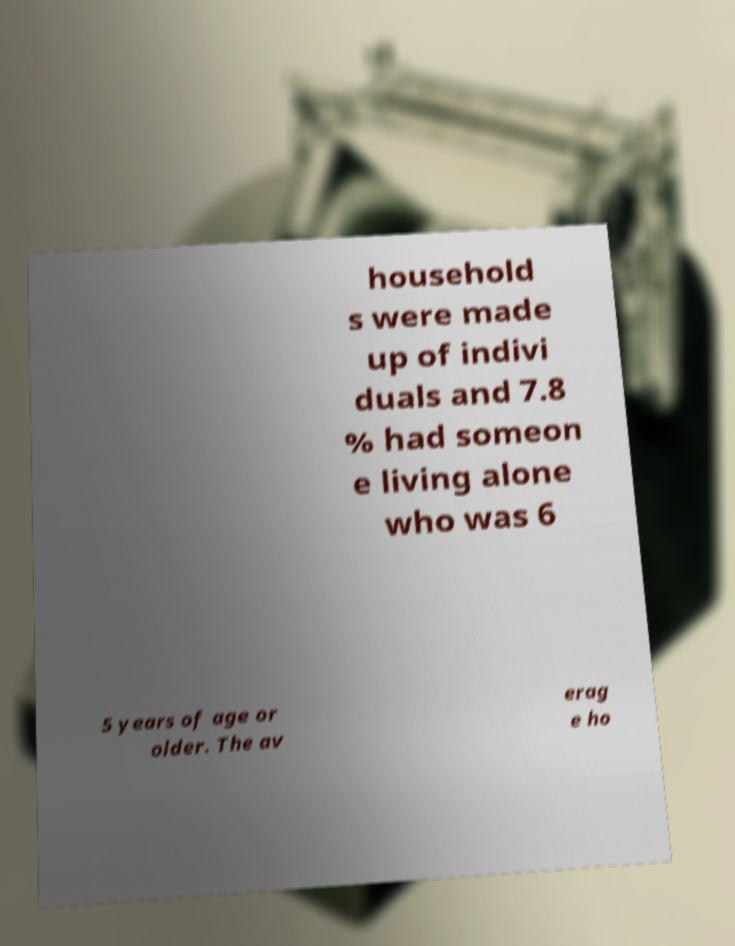I need the written content from this picture converted into text. Can you do that? household s were made up of indivi duals and 7.8 % had someon e living alone who was 6 5 years of age or older. The av erag e ho 